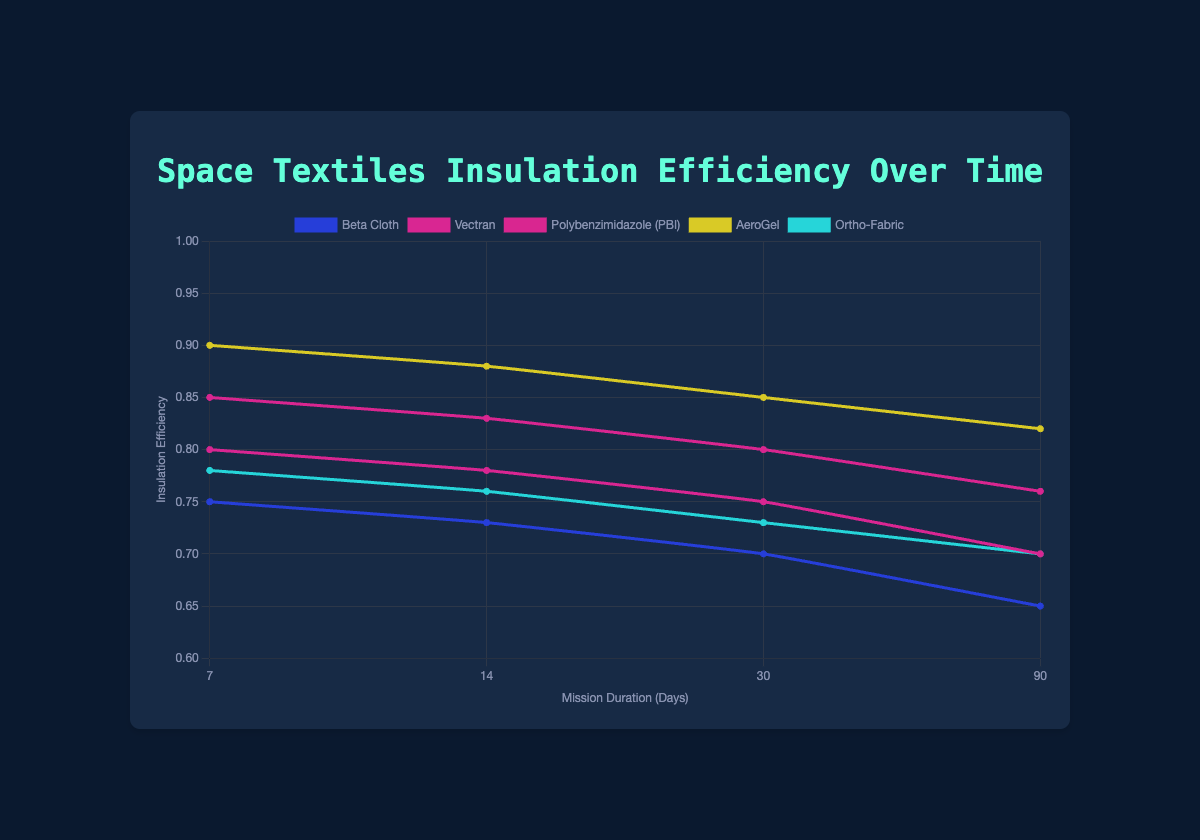What's the overall trend in insulation efficiency for "Beta Cloth" as mission duration increases? As mission duration increases from 7 to 90 days, the insulation efficiency of "Beta Cloth" decreases consistently from 0.75 to 0.65. This indicates a downward trend in insulation efficiency over time.
Answer: Decreasing Which textile has the highest insulation efficiency at 30 days of mission duration? At the 30-day mark, "AeroGel" shows the highest insulation efficiency with a value of 0.85 compared to other textiles.
Answer: AeroGel How does the insulation efficiency of "Vectran" compare to "Ortho-Fabric" at 14 days? At 14 days, "Vectran" has an insulation efficiency of 0.78 while "Ortho-Fabric" has an efficiency of 0.76. This shows that "Vectran" has a higher insulation efficiency than "Ortho-Fabric" at this point.
Answer: Vectran is higher What is the difference in insulation efficiency between "Polybenzimidazole (PBI)" and "Beta Cloth" at 7 days? At 7 days, "Polybenzimidazole (PBI)" has an insulation efficiency of 0.85 while "Beta Cloth" has an efficiency of 0.75. The difference between them is 0.85 - 0.75 = 0.10.
Answer: 0.10 Between "AeroGel" and "Vectran", which textile maintains a higher insulation efficiency over the duration of 90 days? Over the 90 days, "AeroGel" maintains a higher insulation efficiency, ending at 0.82 compared to "Vectran" which ends at 0.70.
Answer: AeroGel What is the average insulation efficiency of "Ortho-Fabric" across all mission durations? The insulation efficiencies of "Ortho-Fabric" across all mission durations are: 0.78, 0.76, 0.73, and 0.70. Calculating the average, (0.78 + 0.76 + 0.73 + 0.70) / 4 = 2.97 / 4 = 0.7425.
Answer: 0.7425 Rank the textiles based on their insulation efficiency at 90 days from the highest to the lowest. At 90 days, the insulation efficiencies are: "AeroGel" (0.82), "Polybenzimidazole (PBI)" (0.76), "Vectran" (0.70), "Ortho-Fabric" (0.70), and "Beta Cloth" (0.65). In descending order:  "AeroGel" (0.82), "Polybenzimidazole (PBI)" (0.76), "Vectran" (0.70), "Ortho-Fabric" (0.70), "Beta Cloth" (0.65).
Answer: AeroGel, Polybenzimidazole (PBI), Vectran, Ortho-Fabric, Beta Cloth What's the overall trend in the insulation efficiencies for all textiles as the mission duration increases? For all textiles, as the mission duration increases from 7 to 90 days, the insulation efficiencies generally show a downward trend.
Answer: Decreasing What is the combined insulation efficiency of "Beta Cloth" and "Vectran" at 7 days? At 7 days, "Beta Cloth" has an insulation efficiency of 0.75 and "Vectran" has 0.80. The combined efficiency is 0.75 + 0.80 = 1.55.
Answer: 1.55 